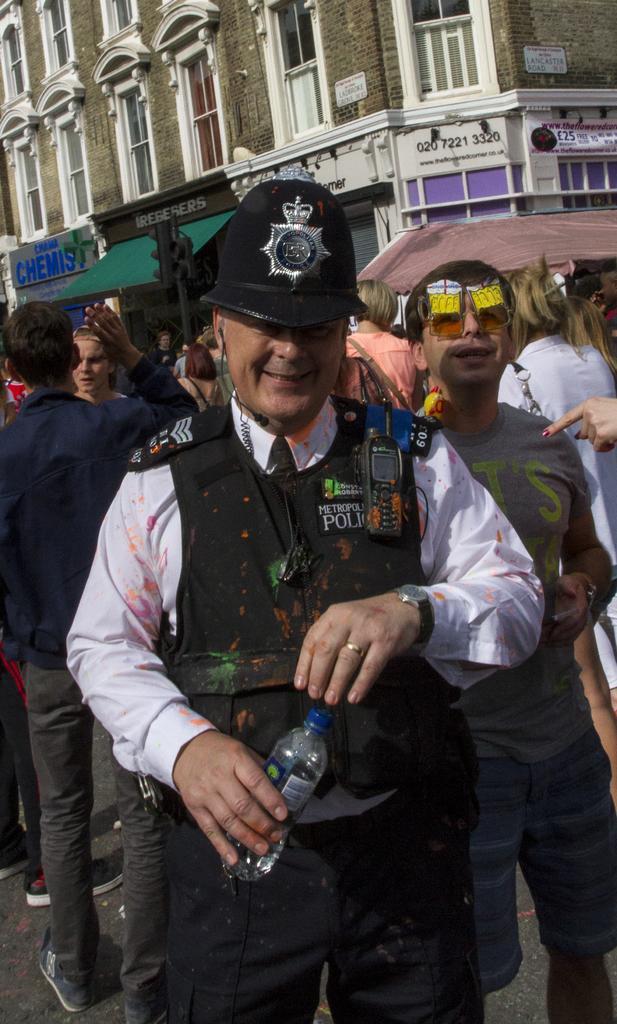How would you summarize this image in a sentence or two? In this image I see a man who is in front and he is holding a bottle and smiling. I can also see there are number of people in the background and the building. 